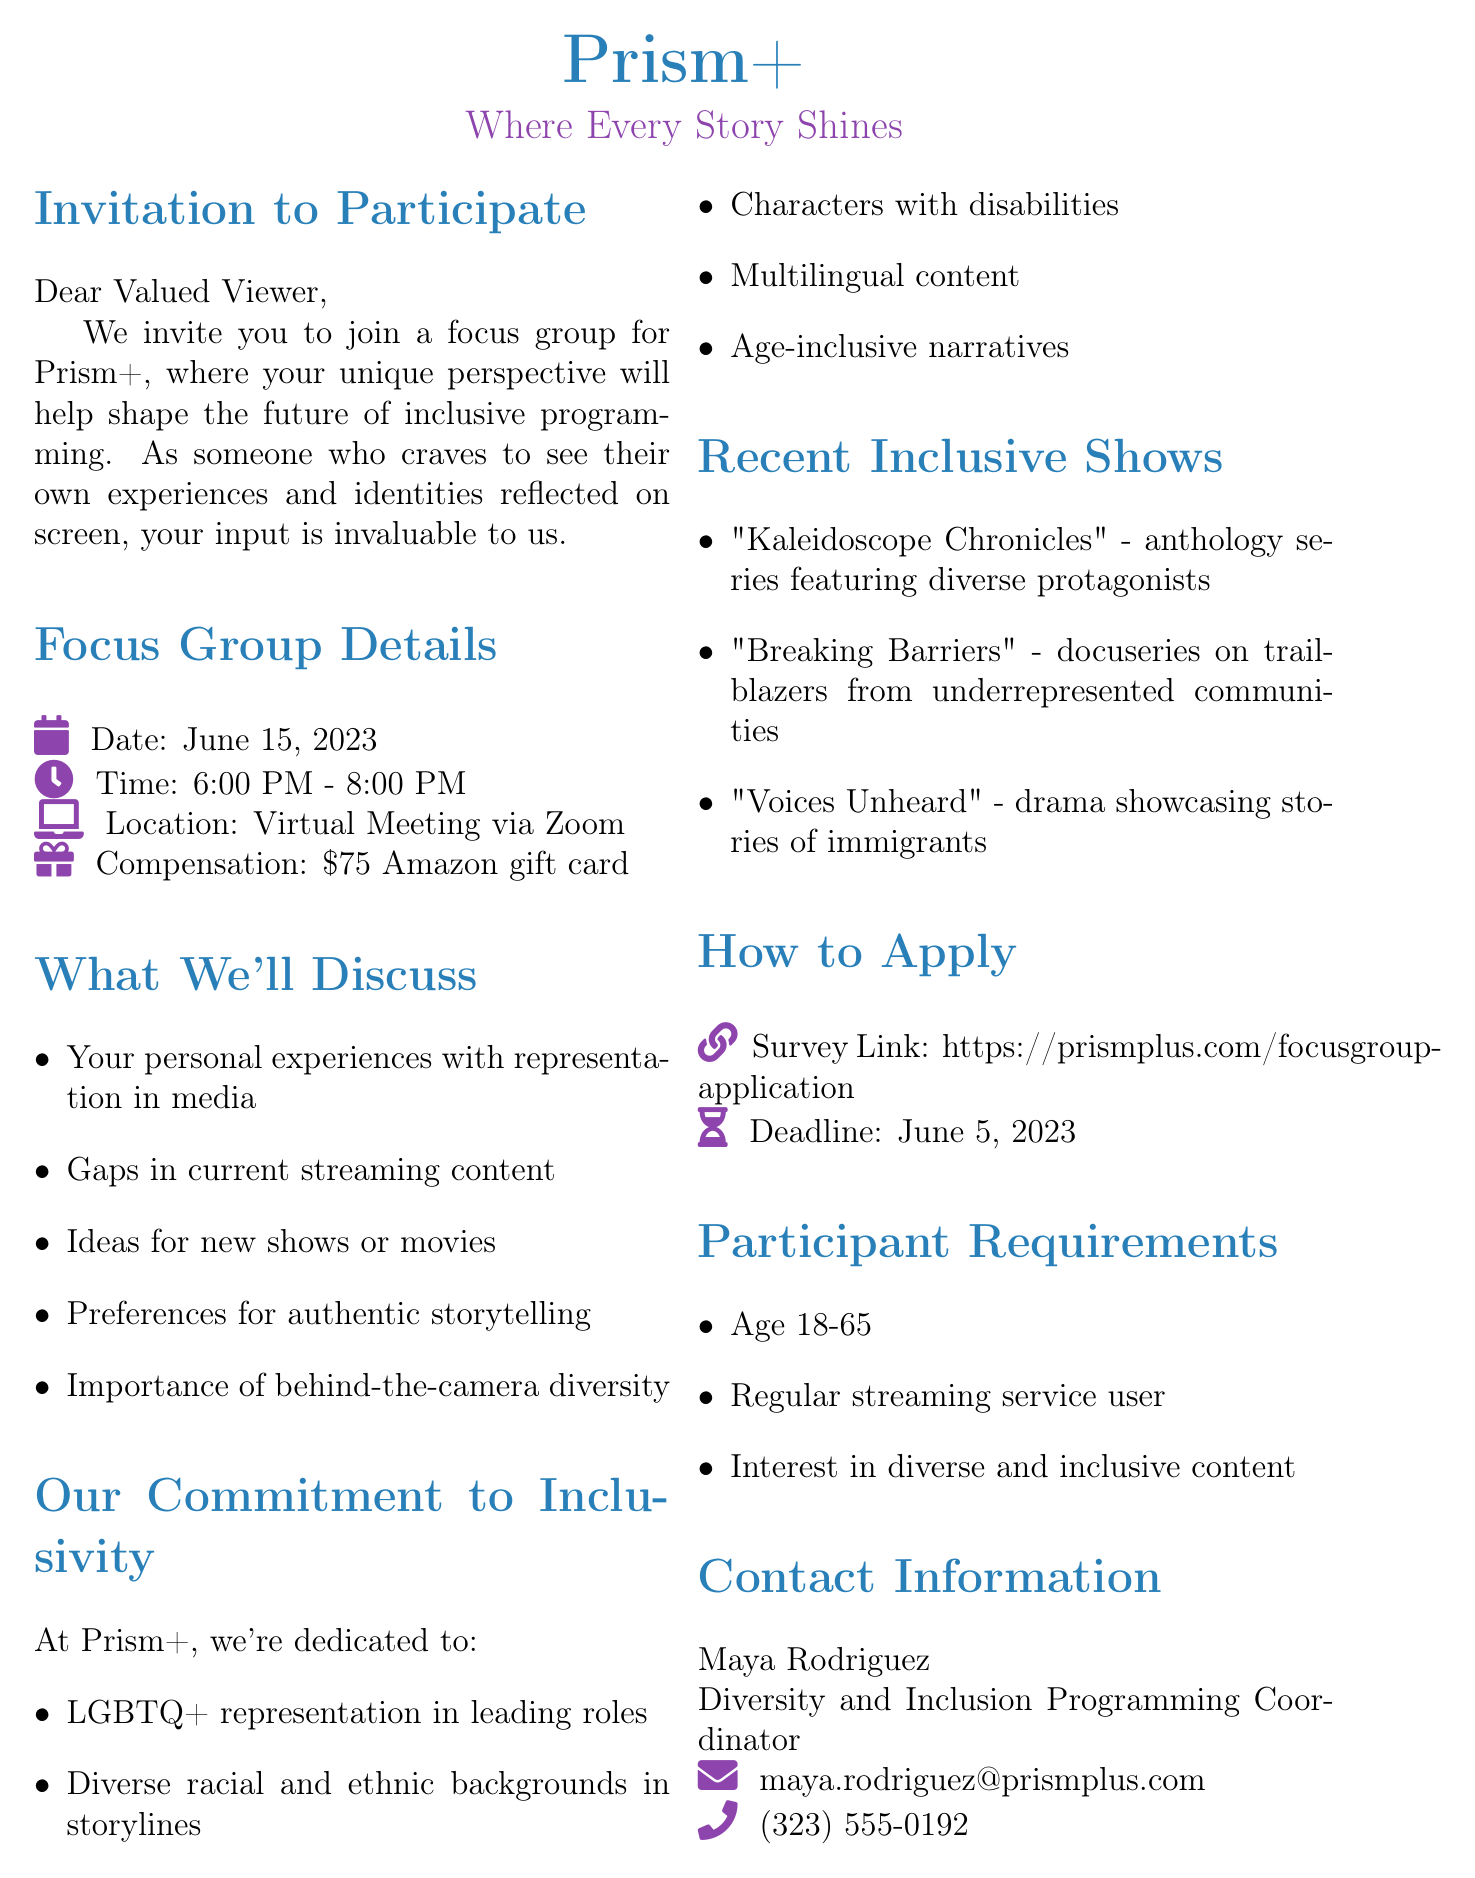What is the date of the focus group? The date of the focus group is specified in the document under "Focus Group Details."
Answer: June 15, 2023 What time does the focus group start? The start time of the focus group is included in the "Focus Group Details."
Answer: 6:00 PM What is the compensation for participants? The document states the amount participants will receive for their involvement in the focus group.
Answer: $75 Amazon gift card Who is the contact person for the focus group? The contact person’s name is found in the "Contact Information" section of the document.
Answer: Maya Rodriguez What are one of the topics to discuss in the focus group? The document lists topics to discuss, focusing on participant experiences with media representation.
Answer: Personal experiences with representation in media How many inclusive programming initiatives are listed? The number of listed initiatives can be calculated from the section that details the platform's commitment to inclusivity.
Answer: Five What is the application process deadline? The deadline for application submissions is clearly mentioned in the "How to Apply" section of the document.
Answer: June 5, 2023 What type of meeting is the focus group held as? The document describes the format of the focus group meeting.
Answer: Virtual Meeting via Zoom What is the mission statement of Prism+? The mission statement is stated at the end of the document that reflects the platform's values.
Answer: At Prism+, we believe in the power of storytelling to connect, inspire, and reflect the diverse experiences of our global audience 